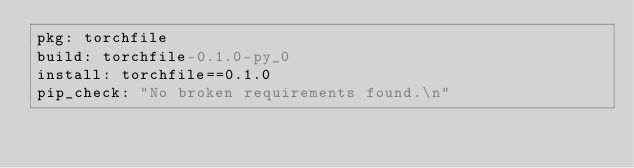<code> <loc_0><loc_0><loc_500><loc_500><_YAML_>pkg: torchfile
build: torchfile-0.1.0-py_0
install: torchfile==0.1.0
pip_check: "No broken requirements found.\n"
</code> 